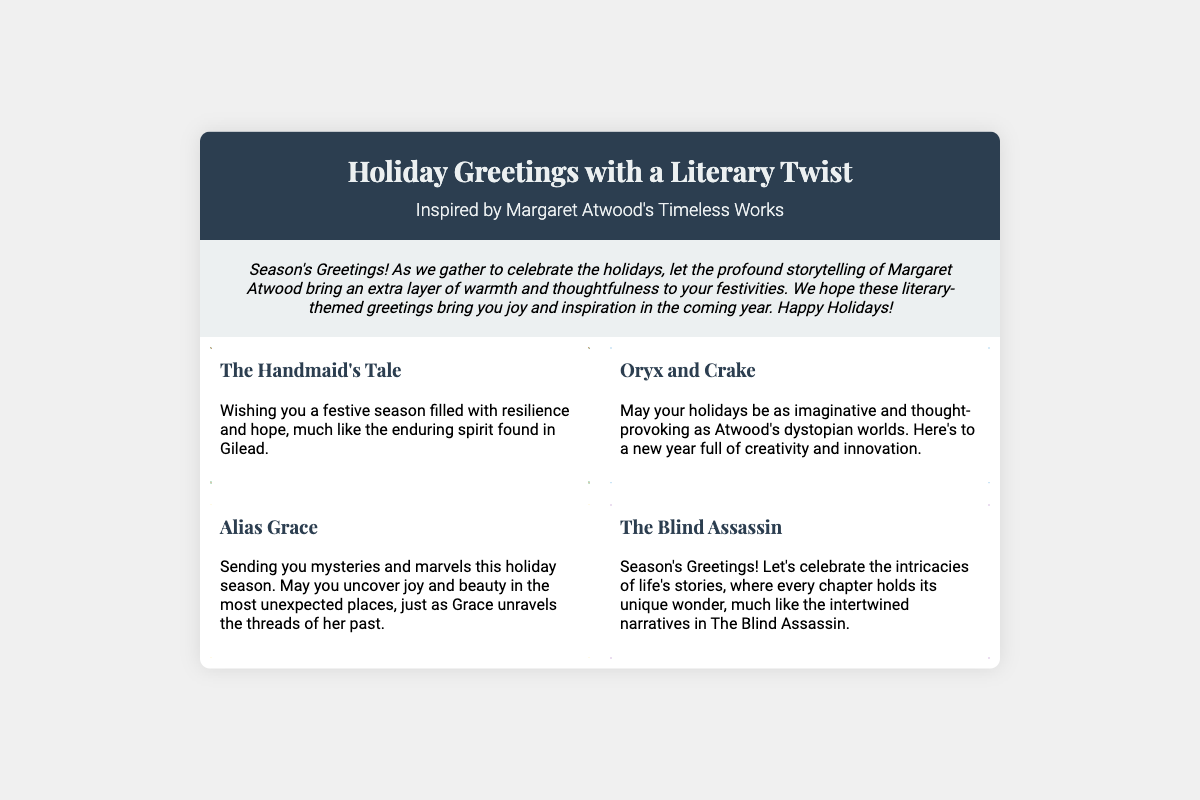what is the title of the greeting card? The title of the greeting card is prominently displayed at the top, stating the theme of the card.
Answer: Holiday Greetings with a Literary Twist who is the author that inspires the card? The greeting card mentions an author whose works are reflected in the holiday greetings.
Answer: Margaret Atwood how many sections are included in the card? The card features a total of four sections, each dedicated to a different book.
Answer: 4 which book is associated with the message about resilience and hope? The greeting in the section highlights a particular book associated with themes of resilience and hope.
Answer: The Handmaid's Tale what festive theme is represented by the border in the Alias Grace section? Each section has a distinct border theme, and this section's border suggests a specific festive representation.
Answer: Scrolls what do the holidays symbolize in the Oryx and Crake section? The greeting in this section indicates a thematic element related to the holidays in connection with the book.
Answer: Creativity and innovation which book's section wishes for joy and beauty in unexpected places? The message in this section specifically references uncovering joy and beauty, related to a particular book by Atwood.
Answer: Alias Grace what colors primarily define the header background? The header background's color scheme plays an important role in the card's overall aesthetics.
Answer: Dark blue and light gray 